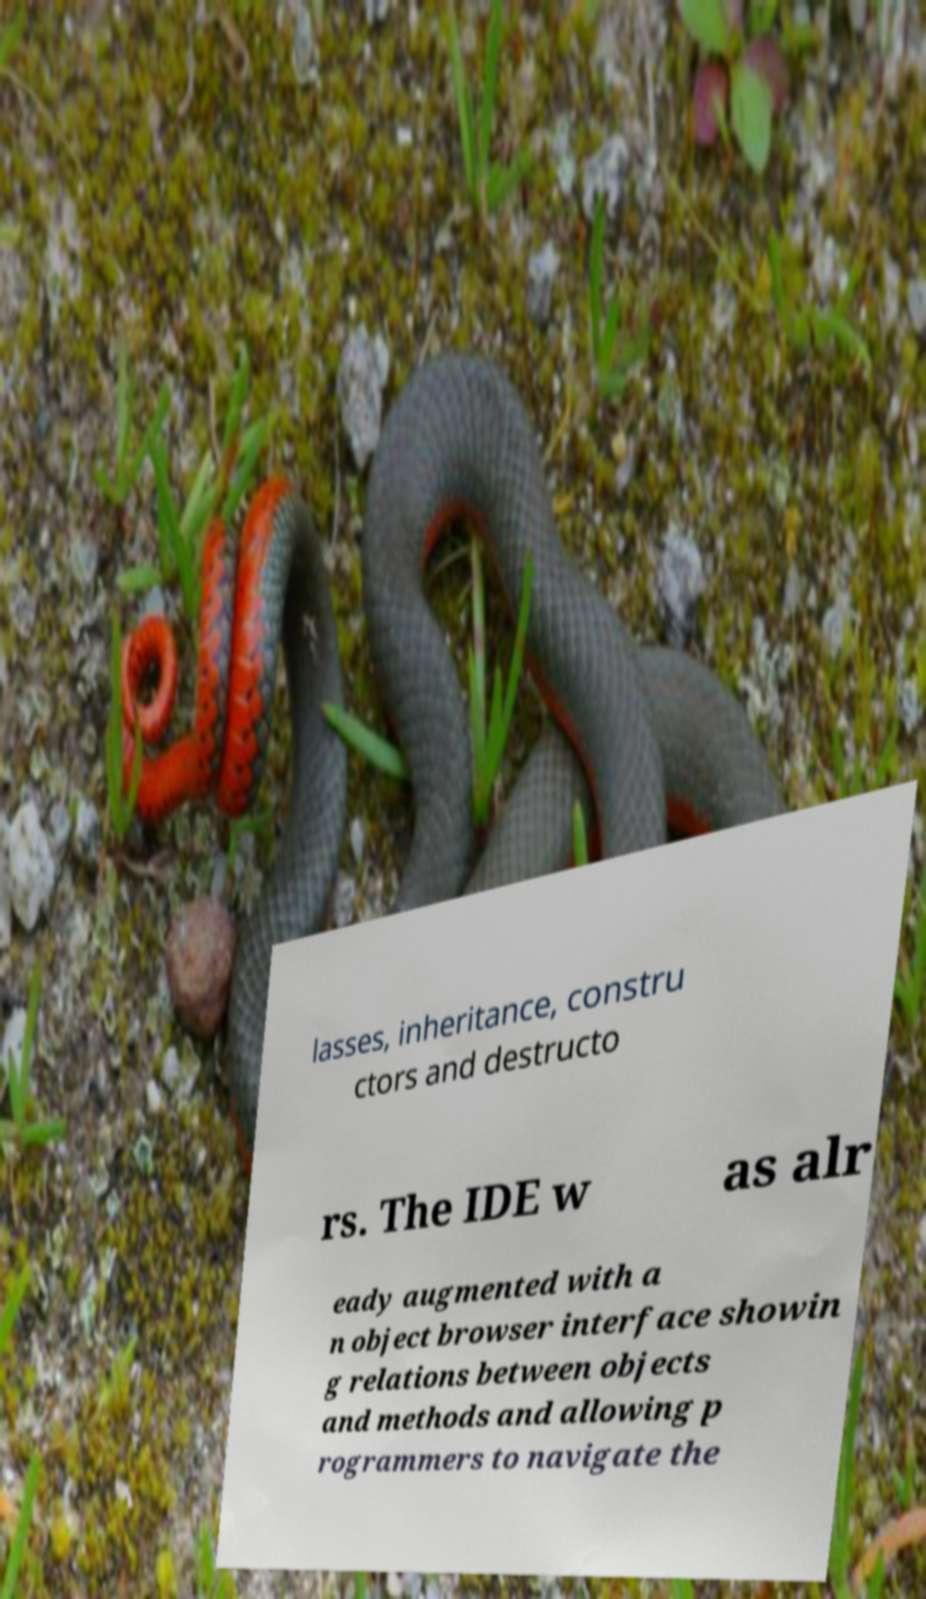Could you assist in decoding the text presented in this image and type it out clearly? lasses, inheritance, constru ctors and destructo rs. The IDE w as alr eady augmented with a n object browser interface showin g relations between objects and methods and allowing p rogrammers to navigate the 